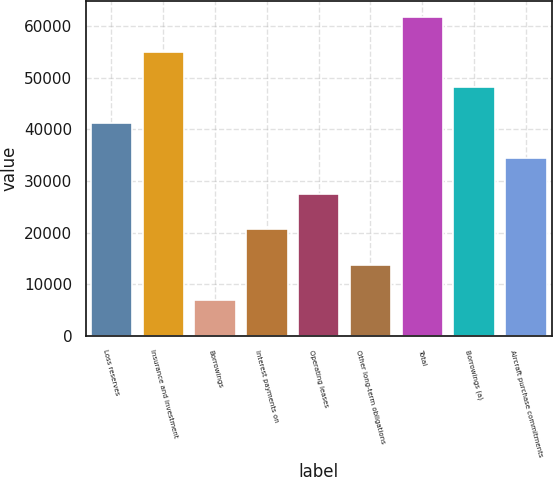Convert chart to OTSL. <chart><loc_0><loc_0><loc_500><loc_500><bar_chart><fcel>Loss reserves<fcel>Insurance and investment<fcel>Borrowings<fcel>Interest payments on<fcel>Operating leases<fcel>Other long-term obligations<fcel>Total<fcel>Borrowings (a)<fcel>Aircraft purchase commitments<nl><fcel>41254.6<fcel>55003.8<fcel>6881.6<fcel>20630.8<fcel>27505.4<fcel>13756.2<fcel>61878.4<fcel>48129.2<fcel>34380<nl></chart> 